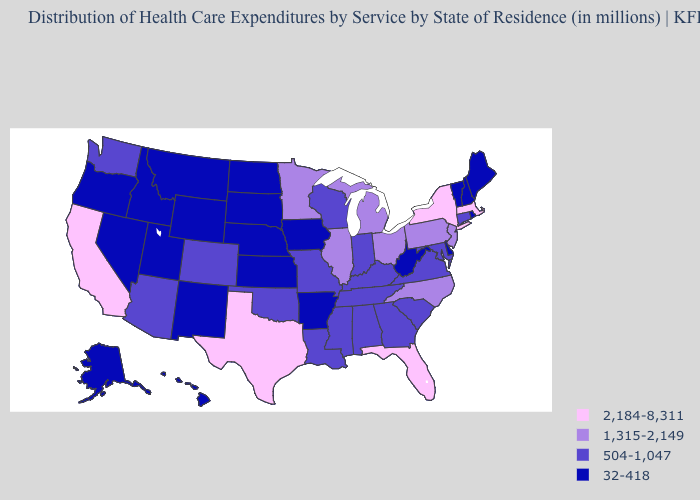Name the states that have a value in the range 1,315-2,149?
Answer briefly. Illinois, Michigan, Minnesota, New Jersey, North Carolina, Ohio, Pennsylvania. Among the states that border Oklahoma , which have the lowest value?
Short answer required. Arkansas, Kansas, New Mexico. What is the value of North Dakota?
Quick response, please. 32-418. Name the states that have a value in the range 1,315-2,149?
Write a very short answer. Illinois, Michigan, Minnesota, New Jersey, North Carolina, Ohio, Pennsylvania. Among the states that border Missouri , does Iowa have the lowest value?
Give a very brief answer. Yes. Does Rhode Island have a lower value than Missouri?
Concise answer only. Yes. Among the states that border Pennsylvania , does Ohio have the lowest value?
Keep it brief. No. Among the states that border Indiana , does Kentucky have the highest value?
Concise answer only. No. Among the states that border Maryland , which have the highest value?
Write a very short answer. Pennsylvania. What is the lowest value in states that border Maine?
Be succinct. 32-418. What is the value of Tennessee?
Answer briefly. 504-1,047. What is the value of Utah?
Quick response, please. 32-418. Name the states that have a value in the range 1,315-2,149?
Answer briefly. Illinois, Michigan, Minnesota, New Jersey, North Carolina, Ohio, Pennsylvania. Which states have the lowest value in the Northeast?
Answer briefly. Maine, New Hampshire, Rhode Island, Vermont. 